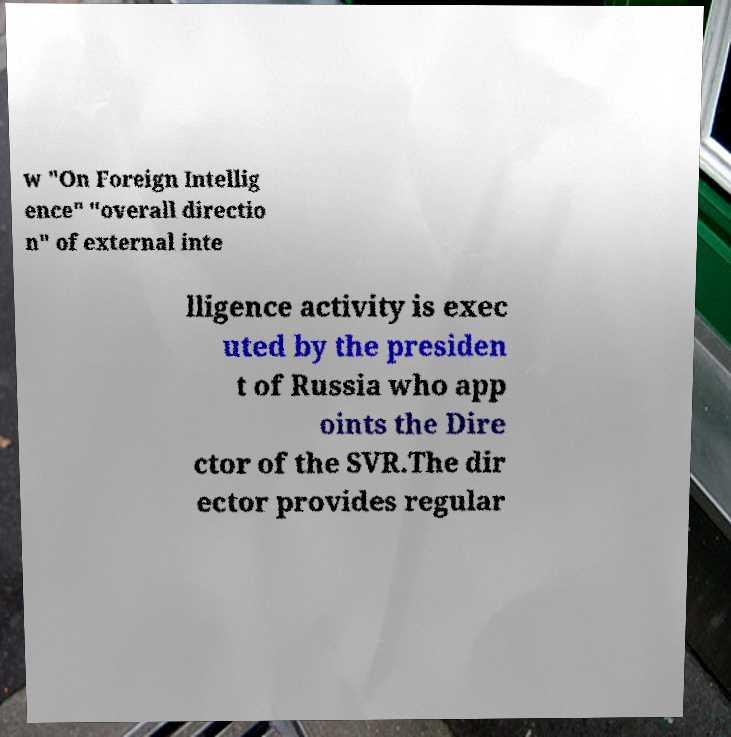Could you extract and type out the text from this image? w "On Foreign Intellig ence" "overall directio n" of external inte lligence activity is exec uted by the presiden t of Russia who app oints the Dire ctor of the SVR.The dir ector provides regular 